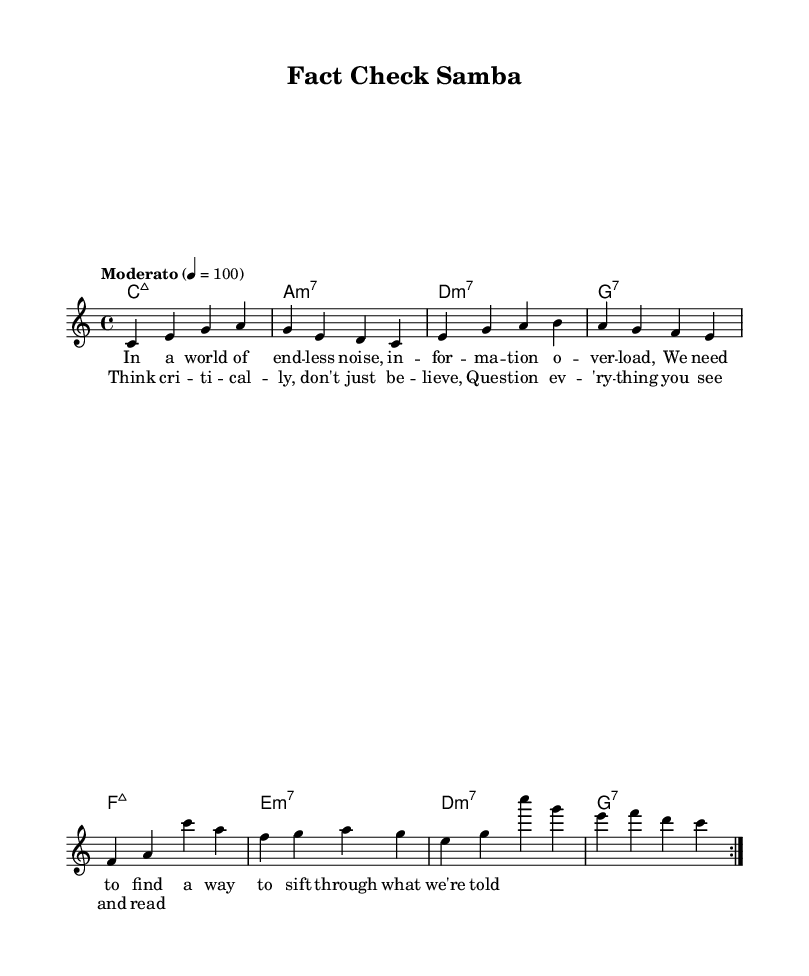What is the key signature of this music? The key signature is C major, which has no sharps or flats.
Answer: C major What is the time signature of this music? The time signature is indicated by the fraction at the beginning of the score, which shows four beats per measure.
Answer: 4/4 What is the tempo marking for this piece? The tempo marking is found below the key and time signatures, indicating the speed for performance, which is Moderato at 100 beats per minute.
Answer: Moderato How many measures are in the repeated section? There is a repeat marked in the music that indicates to go back to the beginning of the section, and it includes eight measures total in the repeat.
Answer: 8 What is the main theme of the lyrics in the chorus? The lyrics suggest a focus on the act of questioning and critical thinking, a central theme in contemporary discussions about information.
Answer: Think critically What type of chords are used in the harmony section? The harmony section consists of various seventh chords, as shown by the chord symbols above the staff.
Answer: Seventh chords What is the overall mood conveyed in the melody and lyrics? The combination of bossa nova rhythms and lyrics focused on critical thinking conveys a thoughtful and contemplative mood, reflecting on modern information overload.
Answer: Thoughtful 